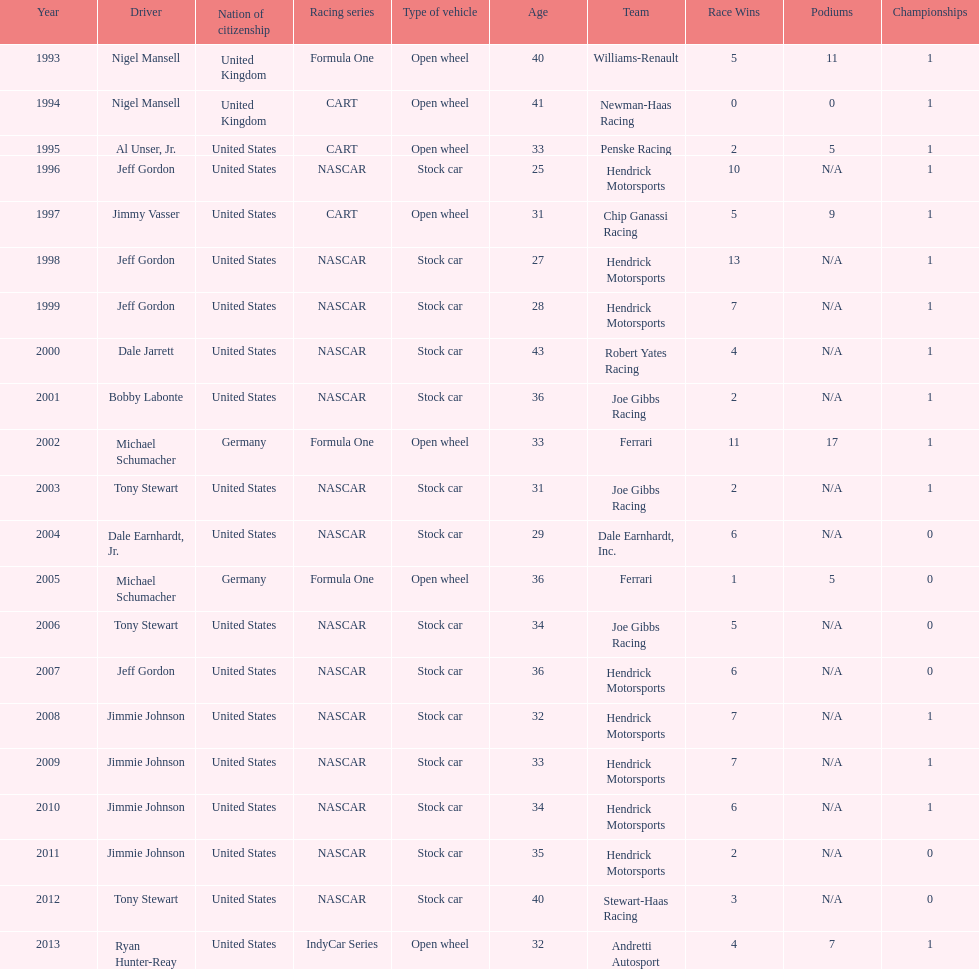Which driver won espy awards 11 years apart from each other? Jeff Gordon. 